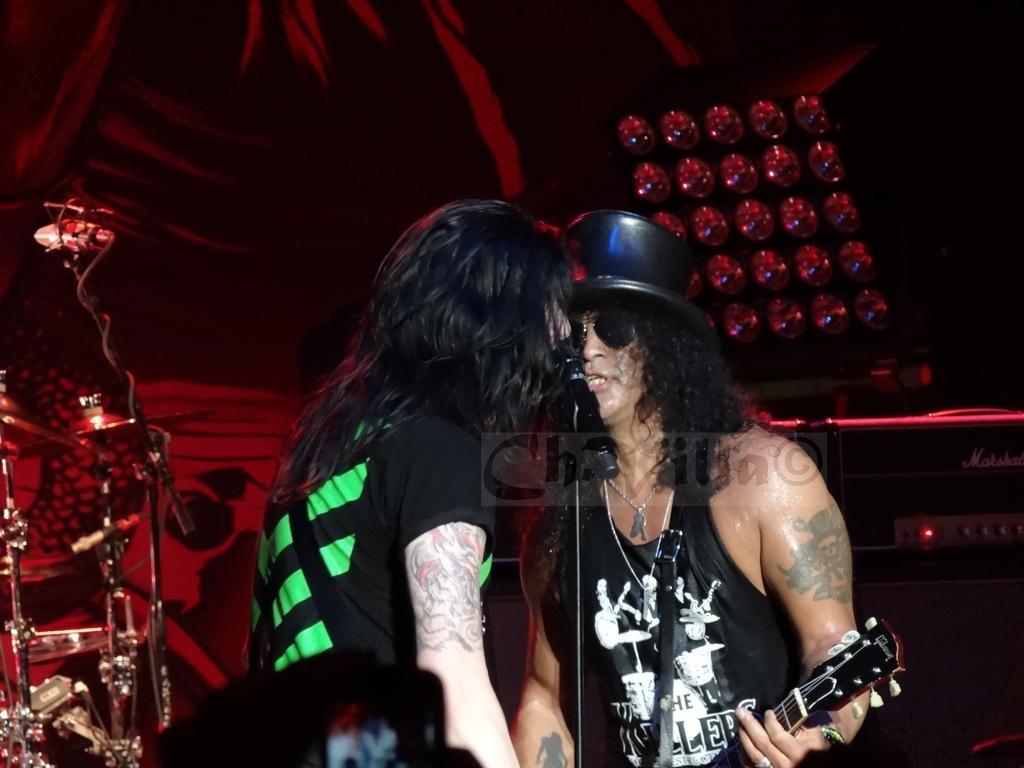Please provide a concise description of this image. In this image i can see two persons standing and playing a musical instrument and singing in front of a micro phone at the back ground i can see few musical instrument and a tent. 